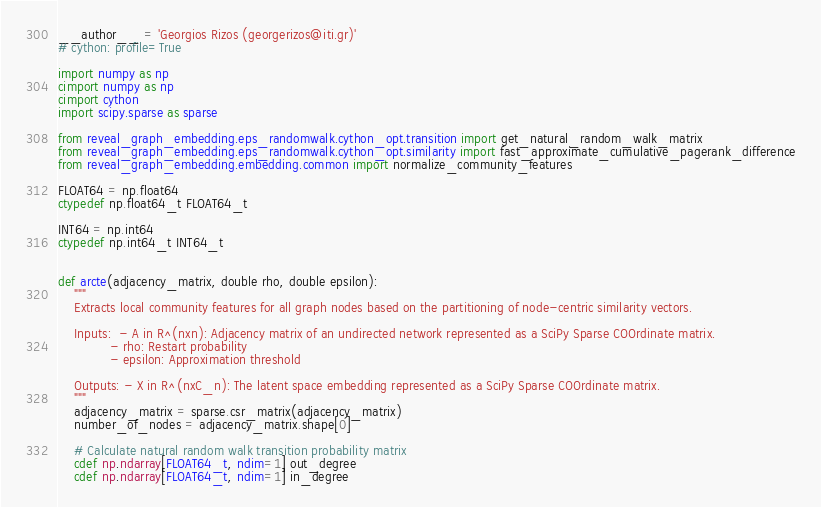Convert code to text. <code><loc_0><loc_0><loc_500><loc_500><_Cython_>__author__ = 'Georgios Rizos (georgerizos@iti.gr)'
# cython: profile=True

import numpy as np
cimport numpy as np
cimport cython
import scipy.sparse as sparse

from reveal_graph_embedding.eps_randomwalk.cython_opt.transition import get_natural_random_walk_matrix
from reveal_graph_embedding.eps_randomwalk.cython_opt.similarity import fast_approximate_cumulative_pagerank_difference
from reveal_graph_embedding.embedding.common import normalize_community_features

FLOAT64 = np.float64
ctypedef np.float64_t FLOAT64_t

INT64 = np.int64
ctypedef np.int64_t INT64_t


def arcte(adjacency_matrix, double rho, double epsilon):
    """
    Extracts local community features for all graph nodes based on the partitioning of node-centric similarity vectors.

    Inputs:  - A in R^(nxn): Adjacency matrix of an undirected network represented as a SciPy Sparse COOrdinate matrix.
             - rho: Restart probability
             - epsilon: Approximation threshold

    Outputs: - X in R^(nxC_n): The latent space embedding represented as a SciPy Sparse COOrdinate matrix.
    """
    adjacency_matrix = sparse.csr_matrix(adjacency_matrix)
    number_of_nodes = adjacency_matrix.shape[0]

    # Calculate natural random walk transition probability matrix
    cdef np.ndarray[FLOAT64_t, ndim=1] out_degree
    cdef np.ndarray[FLOAT64_t, ndim=1] in_degree</code> 